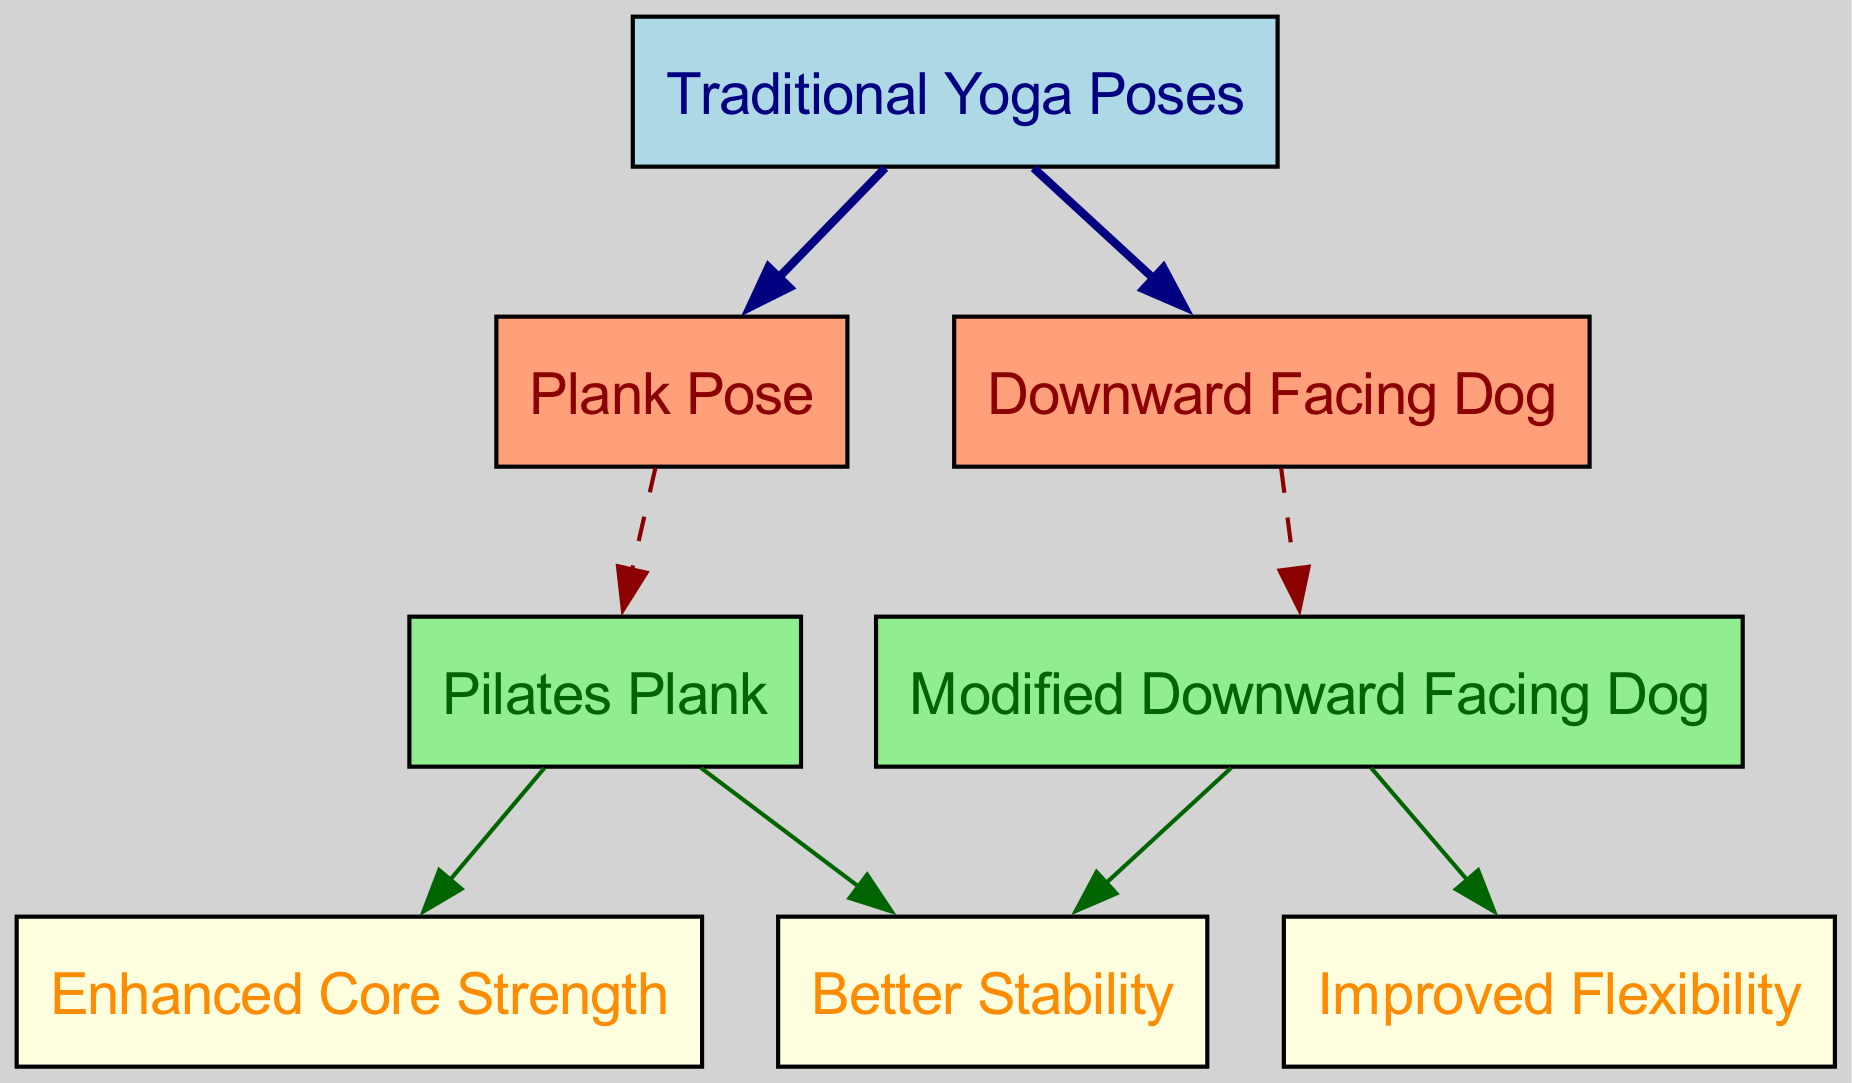What are the two traditional yoga poses represented in the diagram? The diagram indicates two specific traditional yoga poses, which are found as nodes connected to the main "Traditional Yoga Poses" node. They are "Plank Pose" and "Downward Facing Dog."
Answer: Plank Pose, Downward Facing Dog How many edges are present in the diagram? The diagram shows connections between various nodes. To find the total number of edges, we count each connection specified in the edges. There are eight edges depicted in the diagram.
Answer: 8 What benefit is linked to the Pilates Plank? The Pilates Plank node connects to two benefits, which are "Enhanced Core Strength" and "Better Stability." The question specifically asks for one benefit directly linked to the Pilates Plank, which is "Enhanced Core Strength."
Answer: Enhanced Core Strength Which traditional pose leads to two modified poses? "Downward Facing Dog" is shown in the diagram as a traditional yoga pose that leads to a modified version, specifically "Modified Downward Facing Dog." This can be identified by following the edge from "Downward Facing Dog" to "Modified Downward Facing Dog."
Answer: Downward Facing Dog What are the benefits associated with the Modified Downward Facing Dog? The node "Modified Downward Facing Dog" connects to two benefits. By examining the edges, we see it leads to "Improved Flexibility" and "Better Stability." Therefore, both benefits are associated with this modified pose.
Answer: Improved Flexibility, Better Stability Which pose is associated with better stability? Two poses in the diagram are associated with "Better Stability": the "Pilates Plank" and the "Modified Downward Facing Dog." To determine this, we look for edges connecting these poses to the "Better Stability" node.
Answer: Pilates Plank, Modified Downward Facing Dog What is the relationship between the "Plank Pose" and "Pilates Plank"? The "Plank Pose," a traditional yoga pose, transitions to the "Pilates Plank," indicating that the Pilates version is a variation inspired by the traditional pose. This relationship is evident through a directed edge from "Plank Pose" to "Pilates Plank."
Answer: Pilate’s version of Plank What nodes are colored light green in the diagram? In the diagram, the nodes filled with light green color represent the Pilates-inspired modifications, which include "Pilates Plank" and "Modified Downward Facing Dog." These colors indicate their classification in the comparison of yoga and Pilates.
Answer: Pilates Plank, Modified Downward Facing Dog 